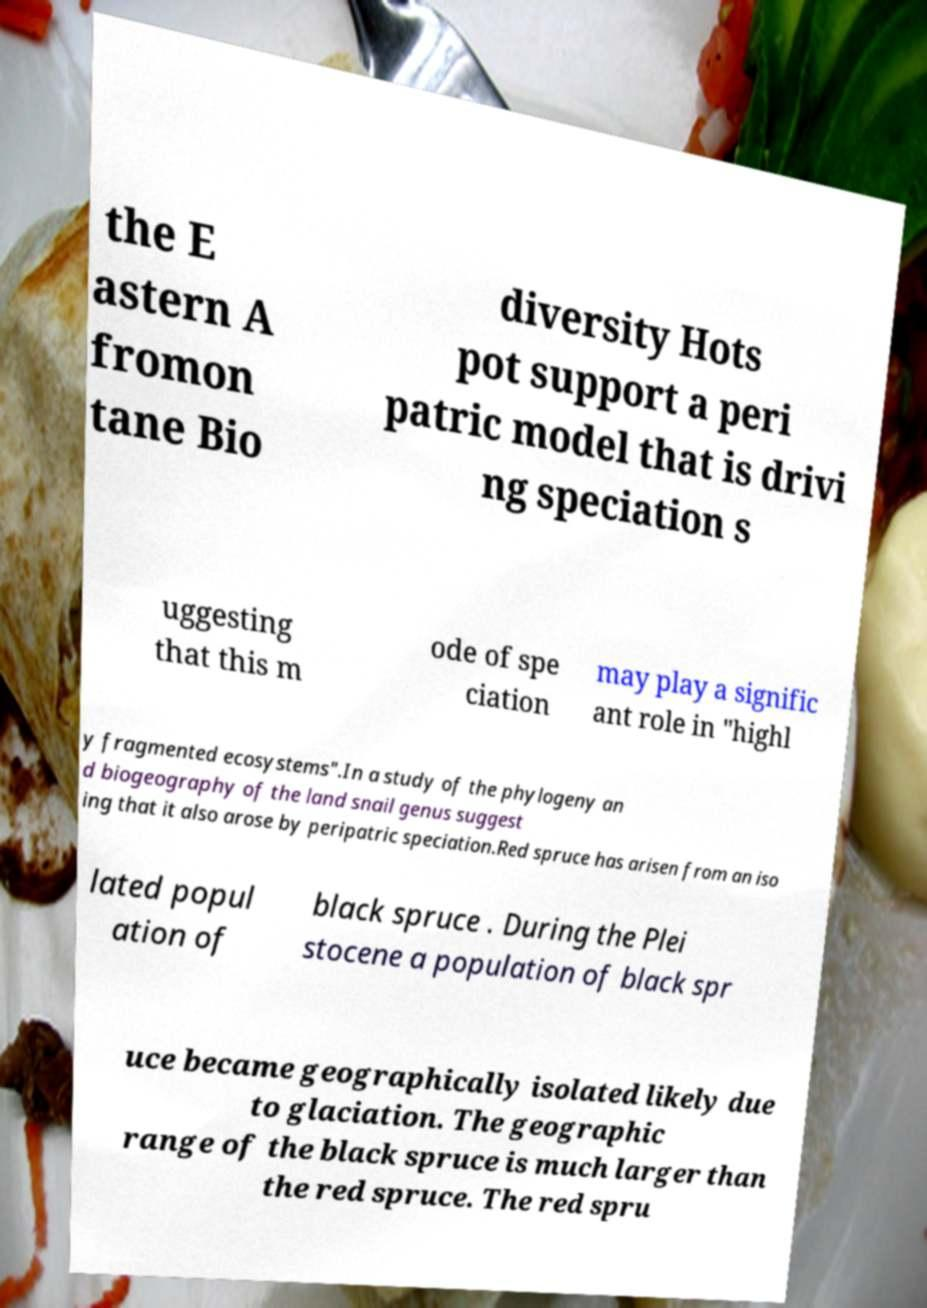I need the written content from this picture converted into text. Can you do that? the E astern A fromon tane Bio diversity Hots pot support a peri patric model that is drivi ng speciation s uggesting that this m ode of spe ciation may play a signific ant role in "highl y fragmented ecosystems".In a study of the phylogeny an d biogeography of the land snail genus suggest ing that it also arose by peripatric speciation.Red spruce has arisen from an iso lated popul ation of black spruce . During the Plei stocene a population of black spr uce became geographically isolated likely due to glaciation. The geographic range of the black spruce is much larger than the red spruce. The red spru 